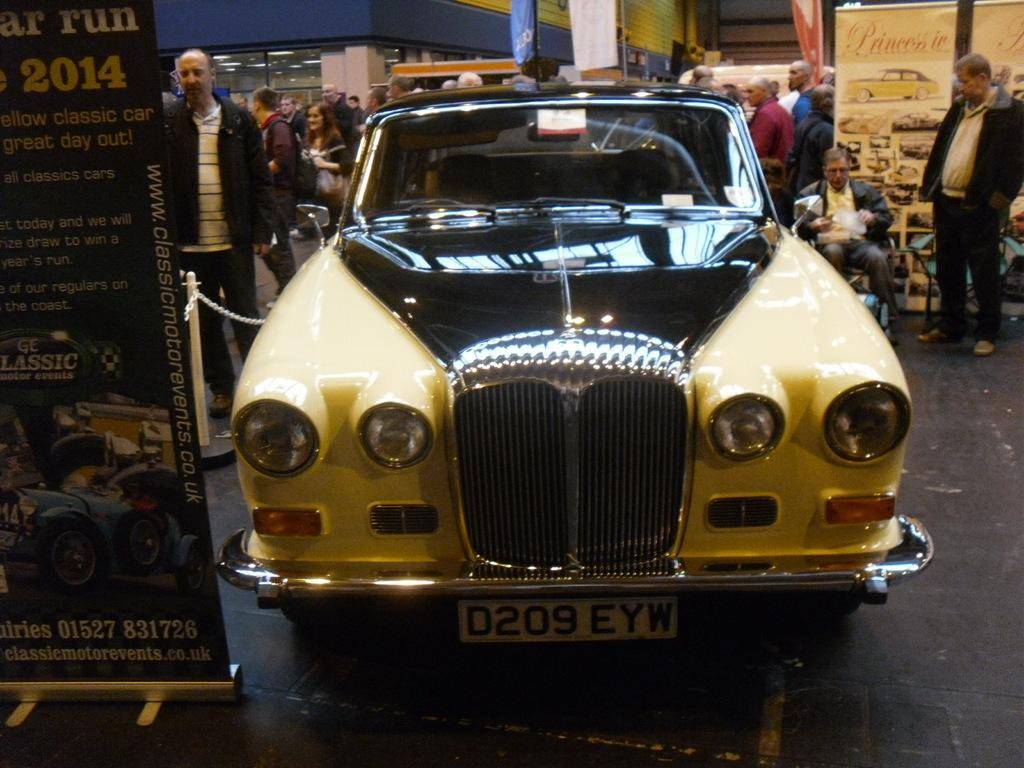<image>
Provide a brief description of the given image. Older car with a model license plate that says D209 EYW. 